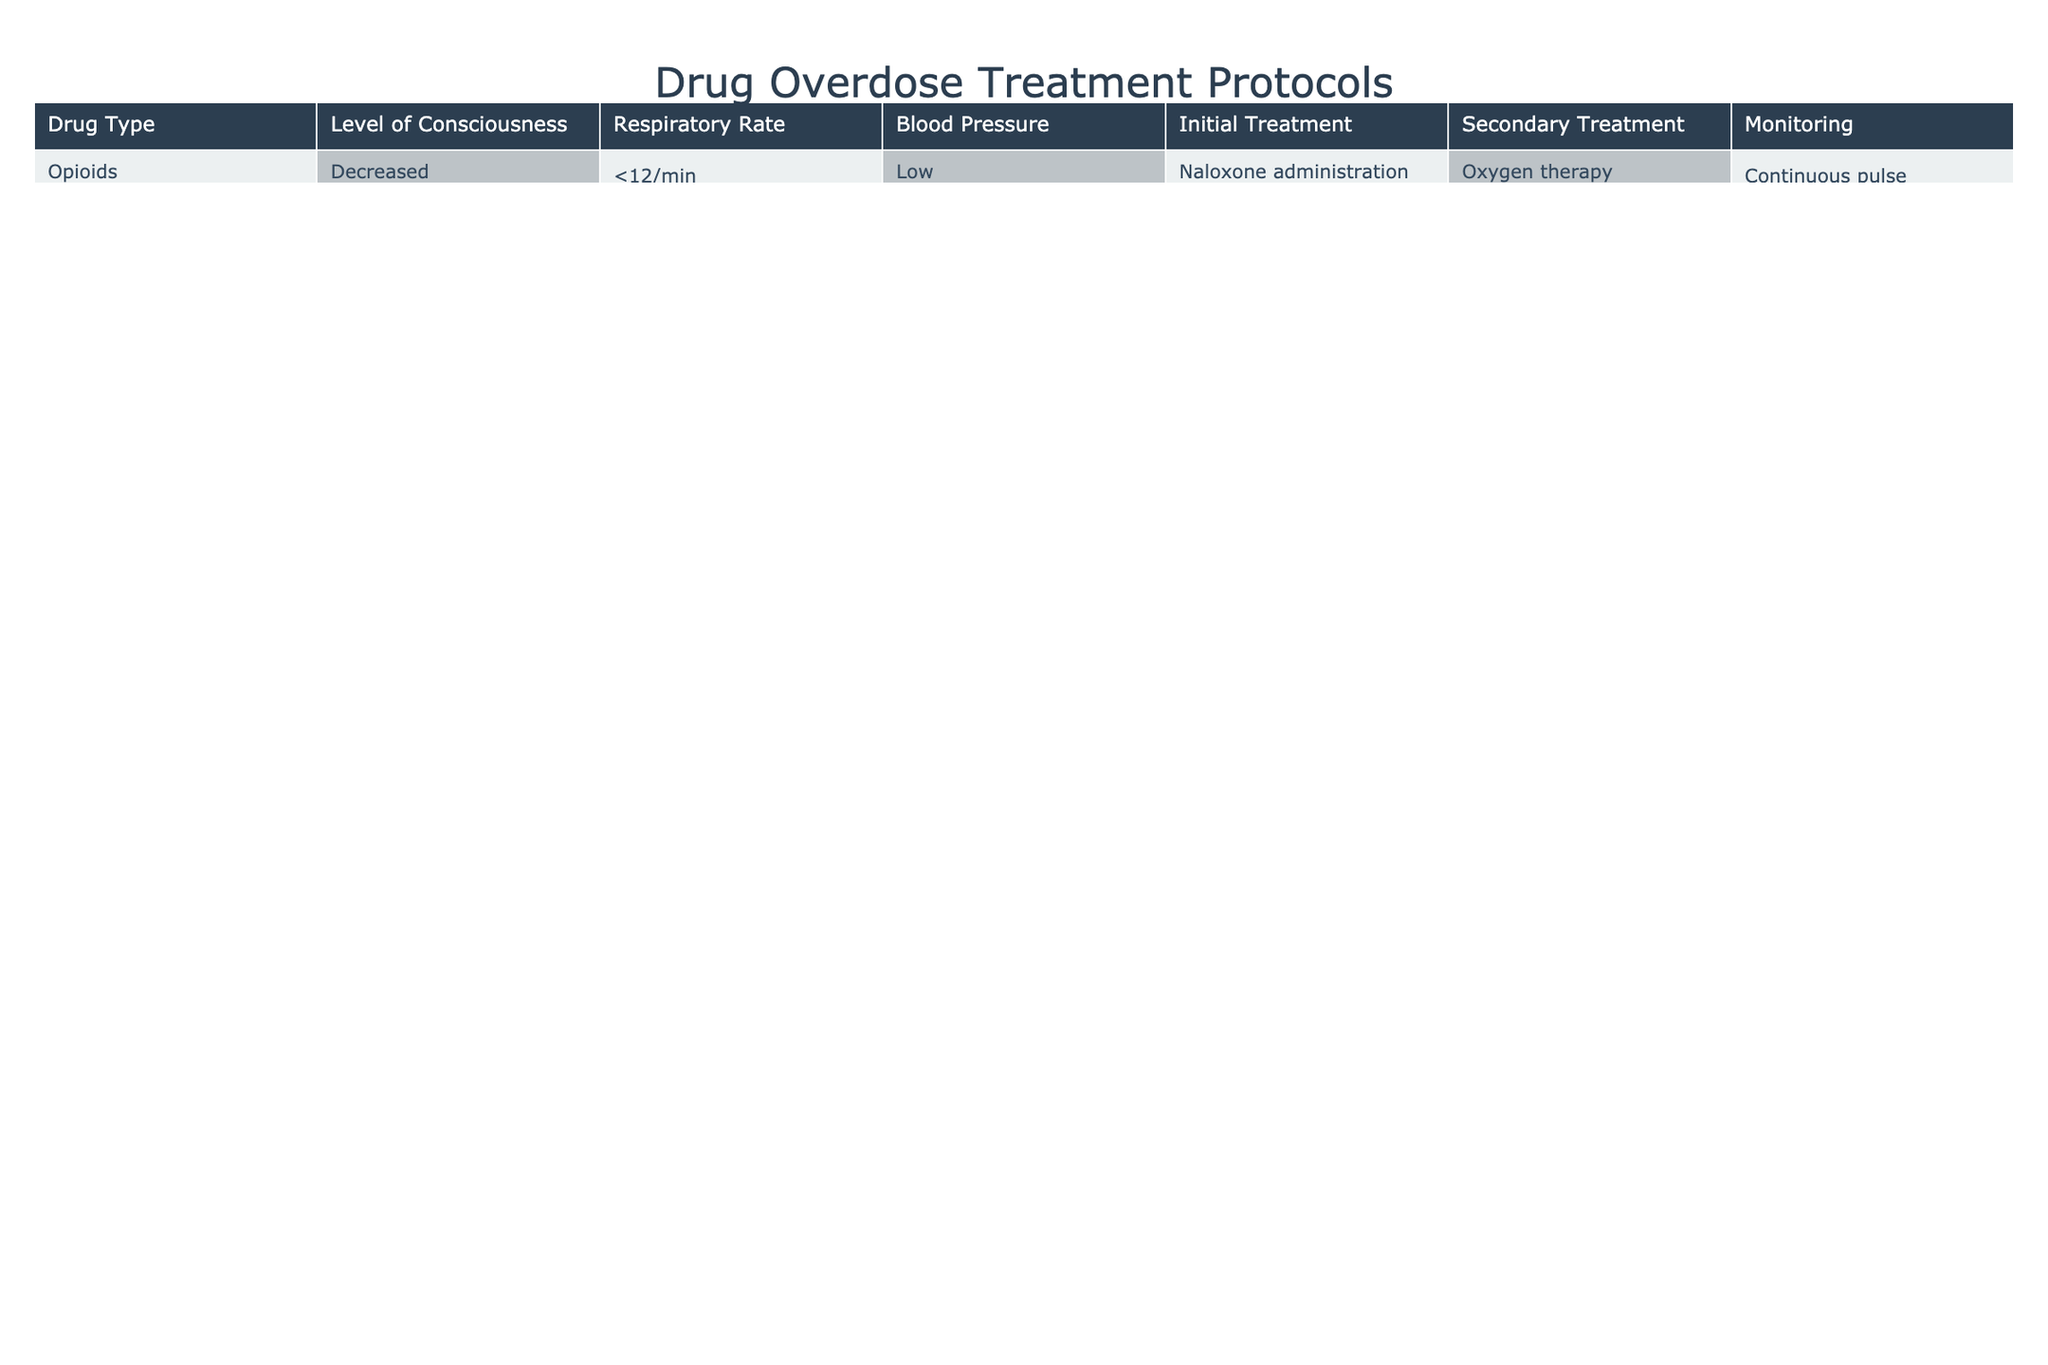What is the initial treatment for opioid overdose? According to the table, the initial treatment for opioid overdose is Naloxone administration.
Answer: Naloxone administration What is the monitoring protocol for benzodiazepine overdose? For benzodiazepine overdose, the table indicates ECG monitoring as the monitoring protocol.
Answer: ECG monitoring Are there any drug types listed that require activated charcoal as a secondary treatment? Yes, the table indicates that both Tricyclic Antidepressants and Acetaminophen require activated charcoal as a secondary treatment.
Answer: Yes What is the average respiratory rate for stimulant overdose? The table shows that the respiratory rate for stimulant overdose is greater than 20/min. Since there's only one entry for stimulants, the average is the same, which is >20/min.
Answer: >20/min For which drug types is the level of consciousness described as "decreased"? The drug types with decreased level of consciousness according to the table are Opioids, Benzodiazepines, Alcohol, GHB, and Tricyclic Antidepressants.
Answer: Opioids, Benzodiazepines, Alcohol, GHB, Tricyclic Antidepressants What are the two initial treatments required for drug types with decreased respiratory rates? The table reveals that the initial treatments for drug types with decreased respiratory rates (Opioids and Alcohol) are Naloxone administration and Thiamine administration respectively.
Answer: Naloxone administration, Thiamine administration Is oxygen therapy used in the treatment of carbon monoxide poisoning? Yes, the table indicates that 100% oxygen therapy is the initial treatment for carbon monoxide poisoning.
Answer: Yes How many drugs listed require continuous monitoring? The table specifies continuous monitoring for Opioids, Tricyclic Antidepressants, GHB, and Carbon Monoxide, totaling four drugs that require continuous monitoring.
Answer: 4 What is the relationship between respiratory rate and initial treatment for benzodiazepine overdose? The table shows that the respiratory rate for benzodiazepine overdose is greater than 20/min, and the initial treatment is Flumazenil administration. The relationship suggests that even with a high rate, Flumazenil is the chosen treatment.
Answer: Flumazenil for >20/min rate What should you monitor if a patient underwent treatment for aspirin overdose? For aspirin overdose treatment, the table indicates that electrolyte monitoring should be performed.
Answer: Electrolyte monitoring 